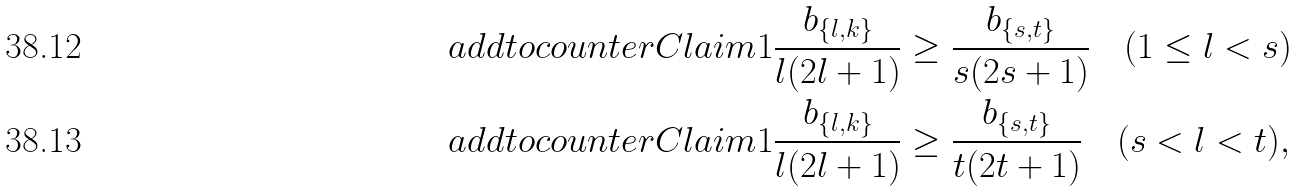Convert formula to latex. <formula><loc_0><loc_0><loc_500><loc_500>\ a d d t o c o u n t e r { C l a i m } { 1 } & \frac { b _ { \{ l , k \} } } { l ( 2 l + 1 ) } \geq \frac { b _ { \{ s , t \} } } { s ( 2 s + 1 ) } \quad ( 1 \leq l < s ) \\ \ a d d t o c o u n t e r { C l a i m } { 1 } & \frac { b _ { \{ l , k \} } } { l ( 2 l + 1 ) } \geq \frac { b _ { \{ s , t \} } } { t ( 2 t + 1 ) } \quad ( s < l < t ) ,</formula> 